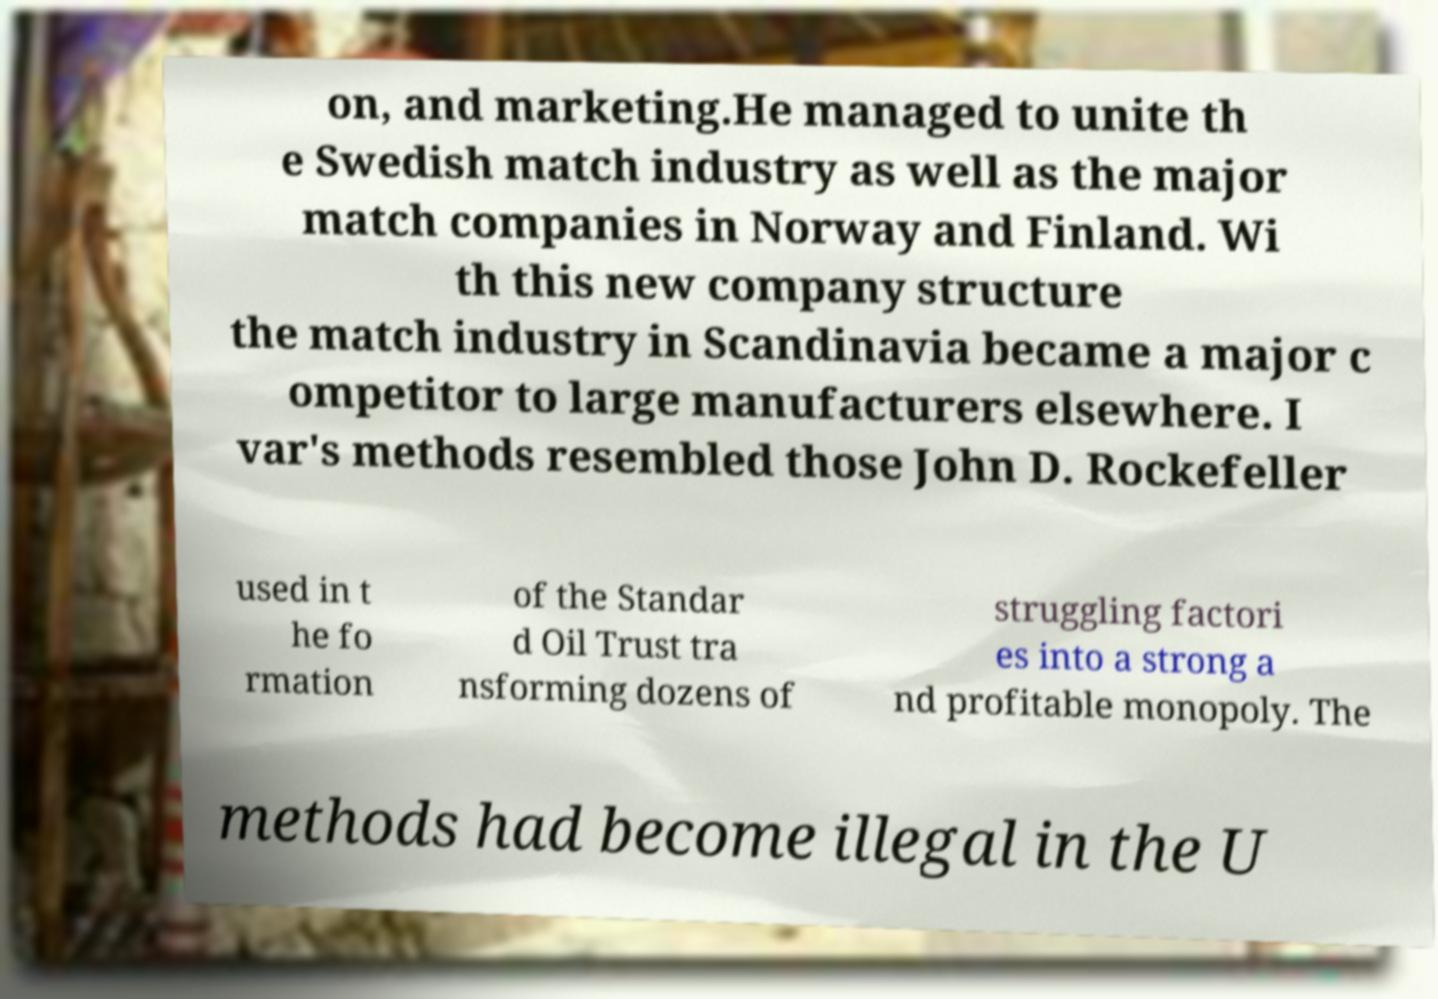I need the written content from this picture converted into text. Can you do that? on, and marketing.He managed to unite th e Swedish match industry as well as the major match companies in Norway and Finland. Wi th this new company structure the match industry in Scandinavia became a major c ompetitor to large manufacturers elsewhere. I var's methods resembled those John D. Rockefeller used in t he fo rmation of the Standar d Oil Trust tra nsforming dozens of struggling factori es into a strong a nd profitable monopoly. The methods had become illegal in the U 